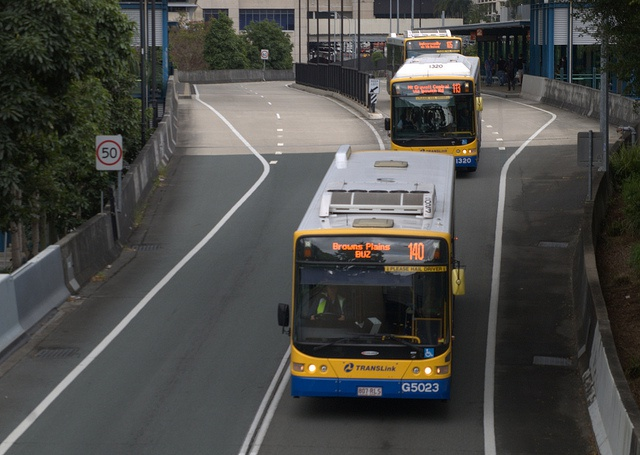Describe the objects in this image and their specific colors. I can see bus in black, darkgray, gray, and navy tones, bus in black, white, gray, and olive tones, bus in black, gray, and salmon tones, people in black, darkgreen, gray, and green tones, and people in black tones in this image. 